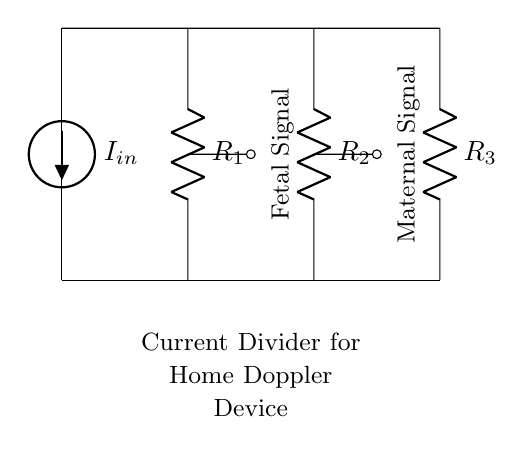What is the total number of resistors in the circuit? There are three resistors indicated in the diagram, labeled R1, R2, and R3.
Answer: 3 What do the two outputs represent in the circuit? The outputs labeled "Fetal Signal" and "Maternal Signal" correspond to the two branches of the current divider, indicating signals from the fetus and the mother, respectively.
Answer: Fetal and Maternal What is the relationship between the input current and the currents through each resistor? In a current divider, the input current splits into the branch currents based on the values of the resistors, following the ratio of the resistances; thus, the current through each resistor is inversely proportional to its resistance.
Answer: Inversely proportional What type of circuit is represented in the diagram? The circuit demonstrates a current divider configuration, which is specifically utilized to split current among multiple paths while maintaining the same voltage across all branches.
Answer: Current divider What is the purpose of the current divider in a home doppler device? The current divider allows separate signals to be measured from the fetal heartbeat and maternal heartbeat, aiding in monitoring both signals simultaneously within the same device.
Answer: Signal monitoring How is the voltage across each resistor related in this current divider configuration? In a current divider, all resistors share the same voltage across them, equal to the voltage provided by the current source, while the current through each resistor varies according to its resistance value.
Answer: Same voltage 